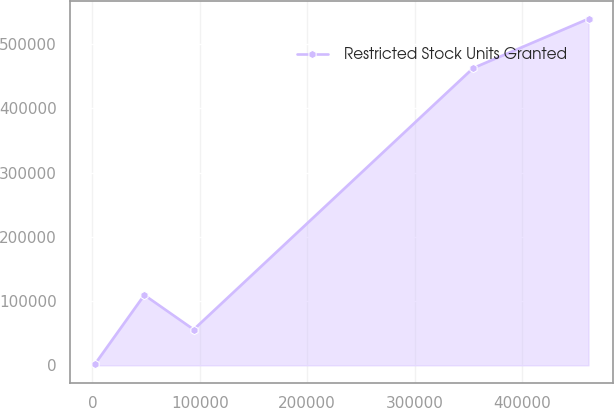Convert chart. <chart><loc_0><loc_0><loc_500><loc_500><line_chart><ecel><fcel>Restricted Stock Units Granted<nl><fcel>2420.84<fcel>1987.12<nl><fcel>48368.5<fcel>109452<nl><fcel>94316.1<fcel>55719.5<nl><fcel>354492<fcel>462563<nl><fcel>461897<fcel>539311<nl></chart> 